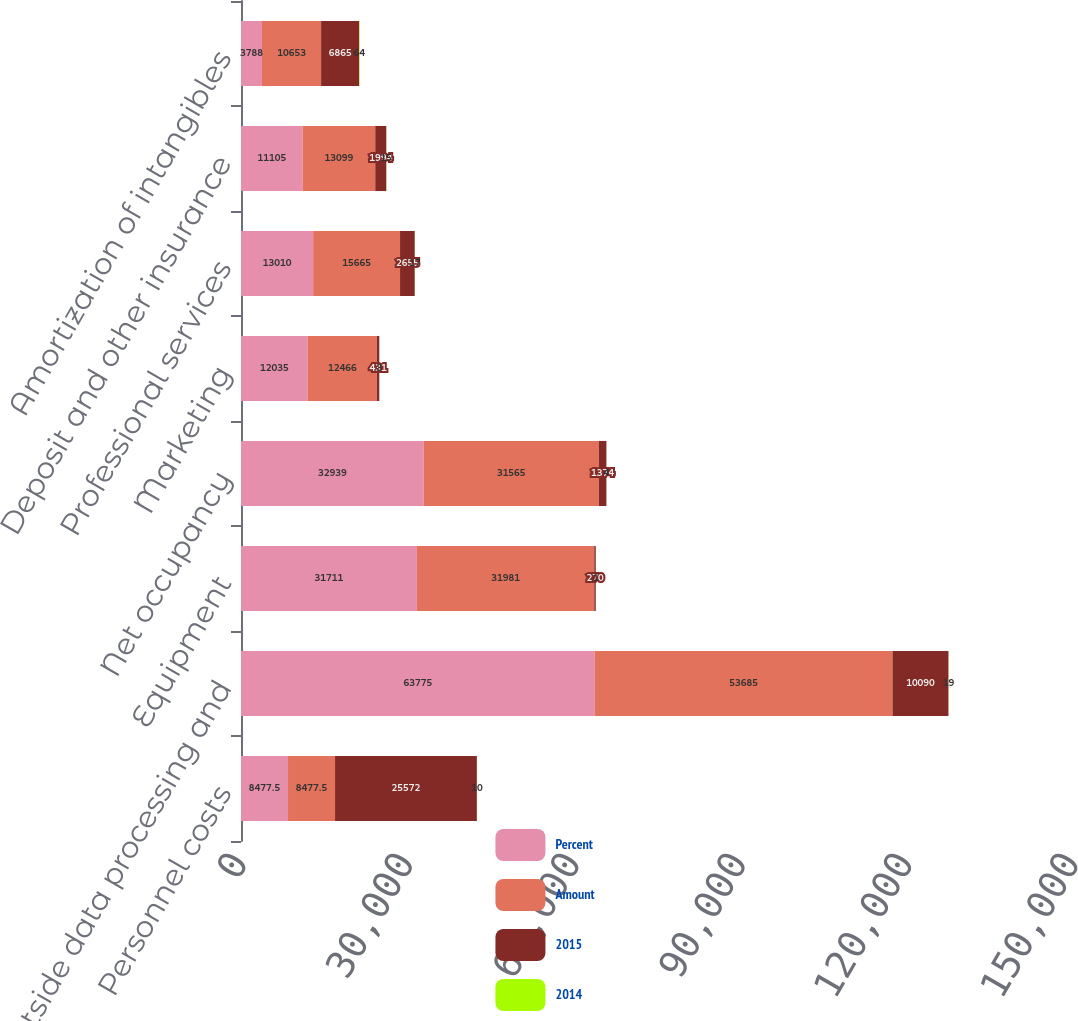<chart> <loc_0><loc_0><loc_500><loc_500><stacked_bar_chart><ecel><fcel>Personnel costs<fcel>Outside data processing and<fcel>Equipment<fcel>Net occupancy<fcel>Marketing<fcel>Professional services<fcel>Deposit and other insurance<fcel>Amortization of intangibles<nl><fcel>Percent<fcel>8477.5<fcel>63775<fcel>31711<fcel>32939<fcel>12035<fcel>13010<fcel>11105<fcel>3788<nl><fcel>Amount<fcel>8477.5<fcel>53685<fcel>31981<fcel>31565<fcel>12466<fcel>15665<fcel>13099<fcel>10653<nl><fcel>2015<fcel>25572<fcel>10090<fcel>270<fcel>1374<fcel>431<fcel>2655<fcel>1994<fcel>6865<nl><fcel>2014<fcel>10<fcel>19<fcel>1<fcel>4<fcel>3<fcel>17<fcel>15<fcel>64<nl></chart> 